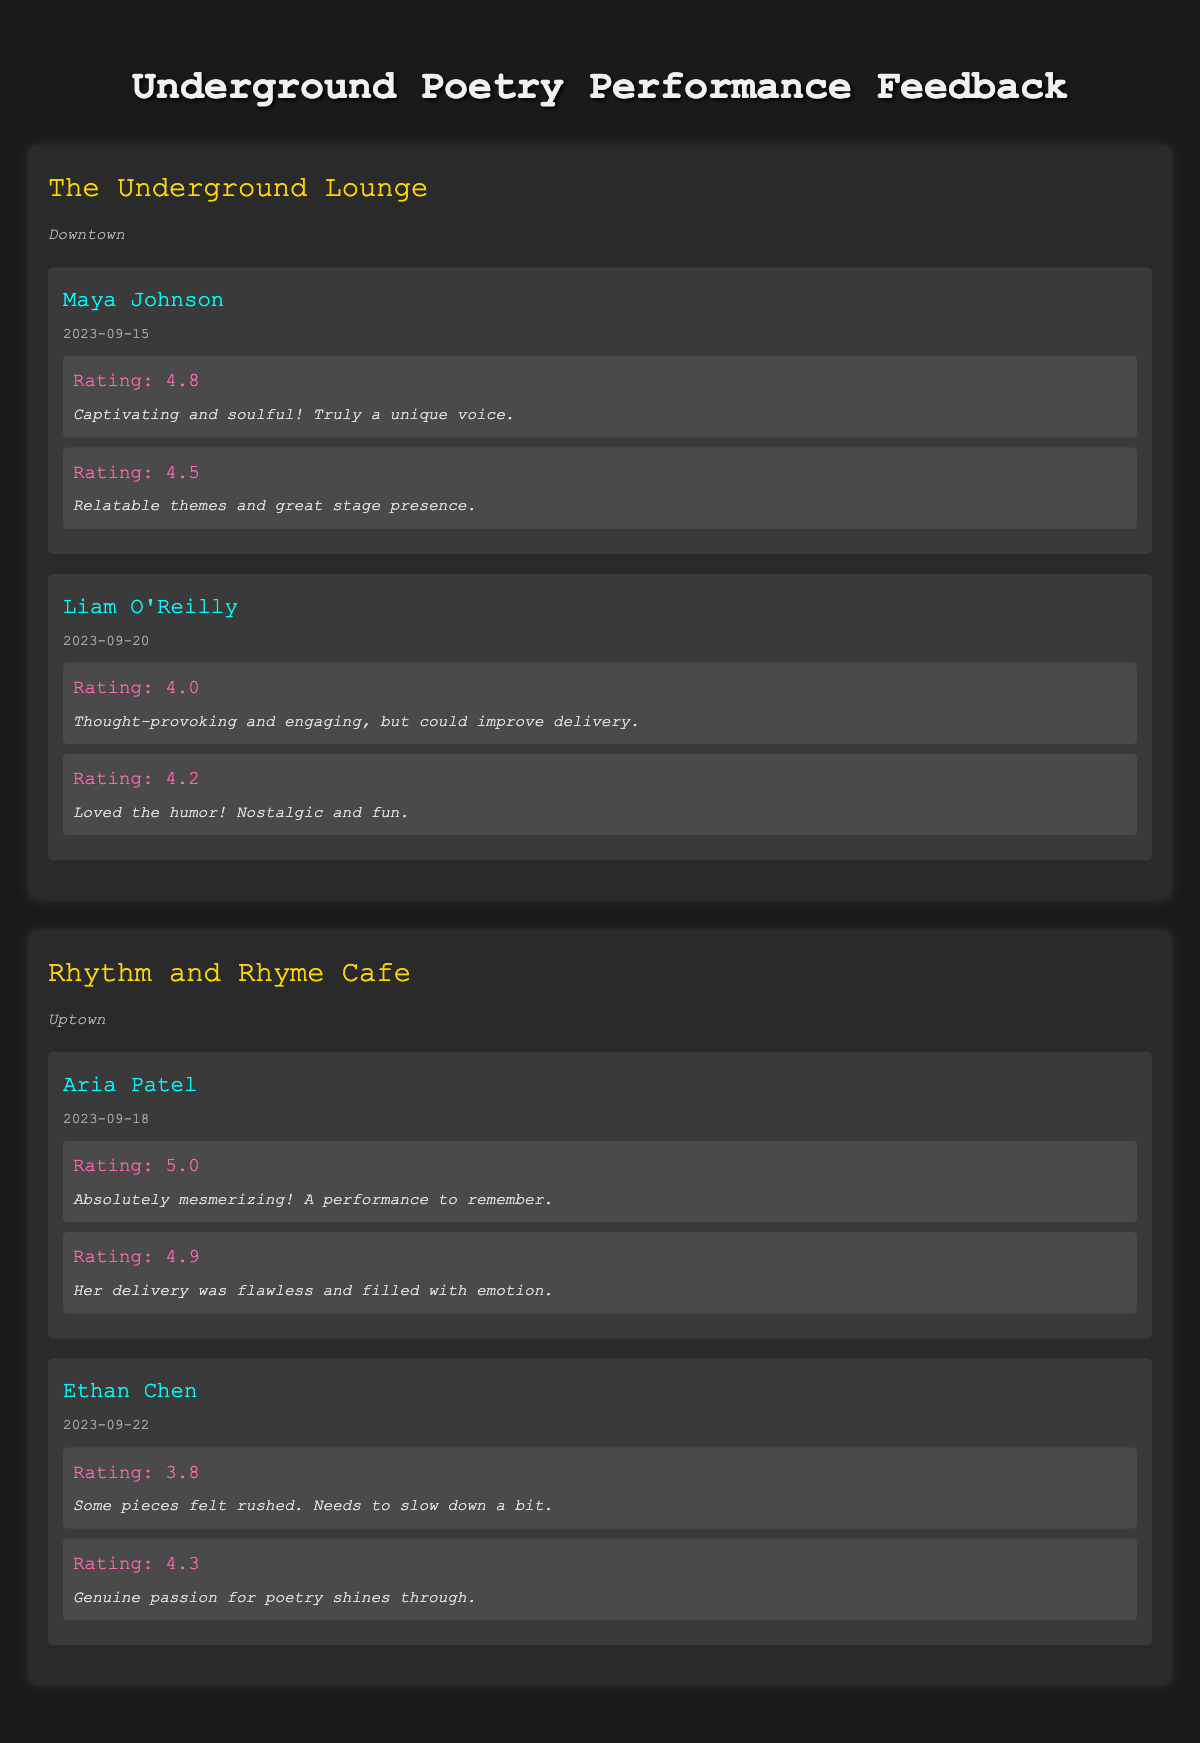What was the highest rating given to any performer? The highest rating given is 5.0, which was received by Aria Patel during her performance on September 18, 2023, at the Rhythm and Rhyme Cafe.
Answer: 5.0 Which venue received feedback for both performers? Both performers, Maya Johnson and Liam O'Reilly, performed at The Underground Lounge, as indicated in the data.
Answer: The Underground Lounge What is the average rating for Liam O'Reilly's performance? To calculate the average, we sum the ratings (4.0 + 4.2 = 8.2) and divide by the number of feedback entries (2). Thus, the average is 8.2/2 = 4.1.
Answer: 4.1 Did any performer receive a rating lower than 4.0? Yes, Ethan Chen received a rating of 3.8 for one of his pieces during his performance.
Answer: Yes Which performer had the most emotional delivery according to the feedback? Aria Patel was noted for her flawless and emotional delivery, receiving ratings of 5.0 and 4.9 which reflect a strong emphasis on her delivery style.
Answer: Aria Patel What is the total number of feedback comments provided for both venues? The total feedback comments can be calculated by counting all the comments: The Underground Lounge has 4 comments (2 for each performer) and Rhythm and Rhyme Cafe has 4 comments (2 for each performer). Thus, the total is 4 + 4 = 8 comments.
Answer: 8 Was the feedback for Ethan Chen more positive than for Liam O'Reilly? To determine this, we compare their average ratings. Liam O'Reilly has an average rating of 4.1 and Ethan Chen has an average rating of (3.8 + 4.3)/2 = 4.05. Since 4.1 is greater than 4.05, Liam O'Reilly's feedback is more positive.
Answer: No Which venue had the performer with the lowest average rating? Ethan Chen has the lowest average rating of 4.05, thus the venue he performed in—Rhythm and Rhyme Cafe—has the lowest average among all performers.
Answer: Rhythm and Rhyme Cafe How many total performances were rated with a score of 4.5 or higher? The ratings that meet this criterion are: 4.8, 4.5, 4.0, 4.2, 5.0, 4.9, and 4.3, totaling 6 ratings out of 8.
Answer: 6 